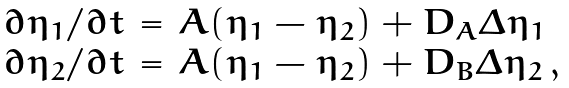<formula> <loc_0><loc_0><loc_500><loc_500>\begin{array} { r c l } \partial \eta _ { 1 } / \partial t & = & A ( \eta _ { 1 } - \eta _ { 2 } ) + D _ { A } \Delta \eta _ { 1 } \\ \partial \eta _ { 2 } / \partial t & = & A ( \eta _ { 1 } - \eta _ { 2 } ) + D _ { B } \Delta \eta _ { 2 } \, , \end{array}</formula> 